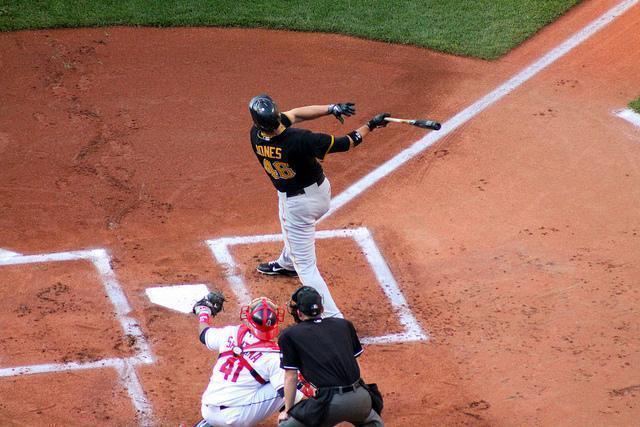What will the standing player do next?
Select the accurate answer and provide justification: `Answer: choice
Rationale: srationale.`
Options: Sit, squat, run, hide. Answer: run.
Rationale: After hitting the ball the batter will run to first as fast as he can. 